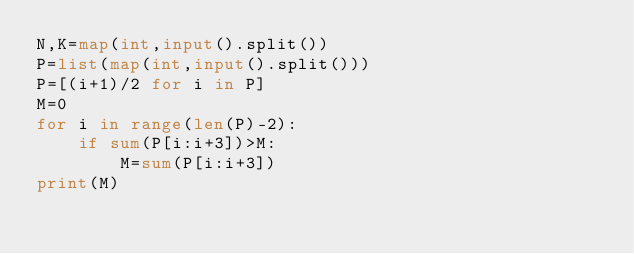<code> <loc_0><loc_0><loc_500><loc_500><_Python_>N,K=map(int,input().split())
P=list(map(int,input().split()))
P=[(i+1)/2 for i in P]
M=0
for i in range(len(P)-2):
    if sum(P[i:i+3])>M:
        M=sum(P[i:i+3])
print(M)</code> 